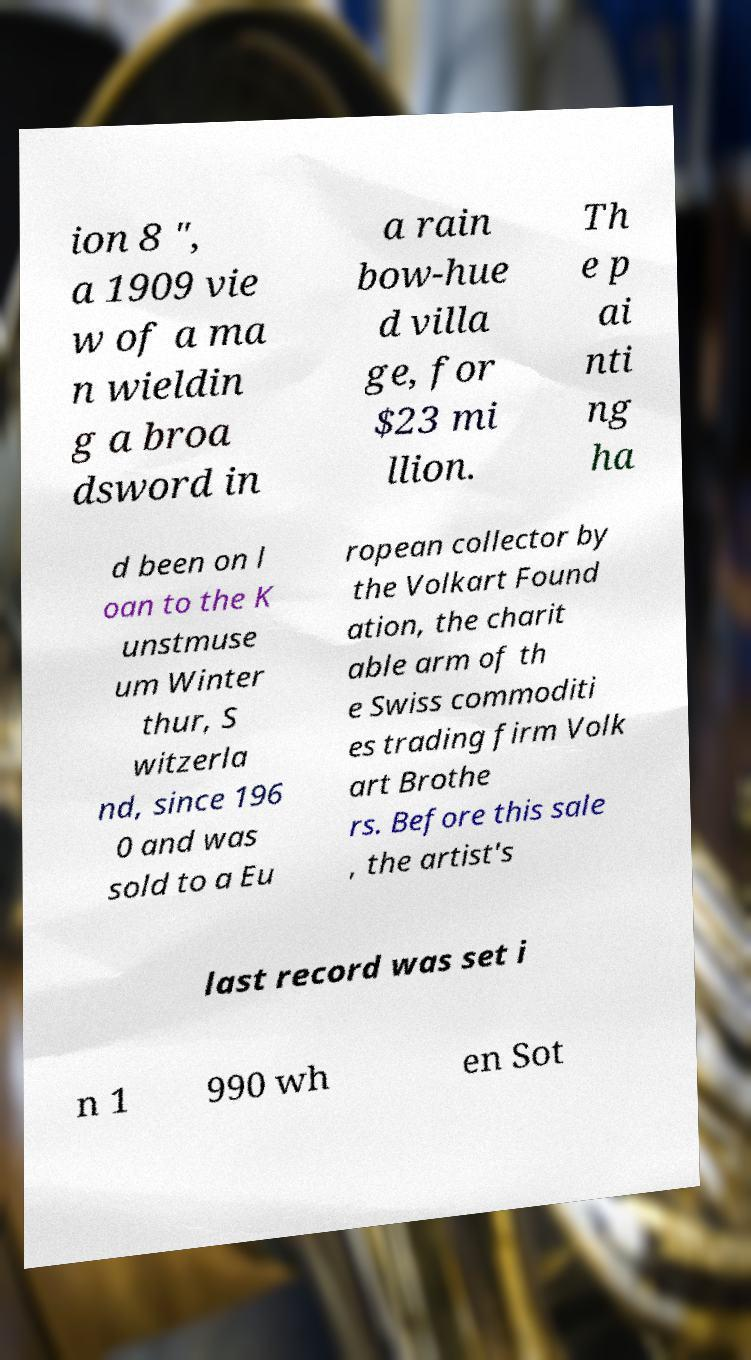What messages or text are displayed in this image? I need them in a readable, typed format. ion 8 ", a 1909 vie w of a ma n wieldin g a broa dsword in a rain bow-hue d villa ge, for $23 mi llion. Th e p ai nti ng ha d been on l oan to the K unstmuse um Winter thur, S witzerla nd, since 196 0 and was sold to a Eu ropean collector by the Volkart Found ation, the charit able arm of th e Swiss commoditi es trading firm Volk art Brothe rs. Before this sale , the artist's last record was set i n 1 990 wh en Sot 